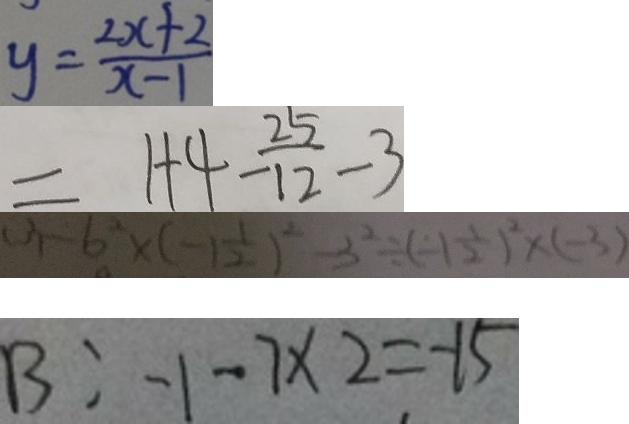<formula> <loc_0><loc_0><loc_500><loc_500>y = \frac { 2 x + 2 } { x - 1 } 
 = 1 + 4 - \frac { 2 5 } { 1 2 } - 3 
 ( 3 ) - 6 ^ { 2 } \times ( - 1 \frac { 1 } { 2 } ) ^ { 2 } - 3 ^ { 2 } \div ( - 1 \frac { 1 } { 2 } ) ^ { 2 } \times ( - 3 ) 
 B : - 1 - 7 \times 2 = - 1 5</formula> 